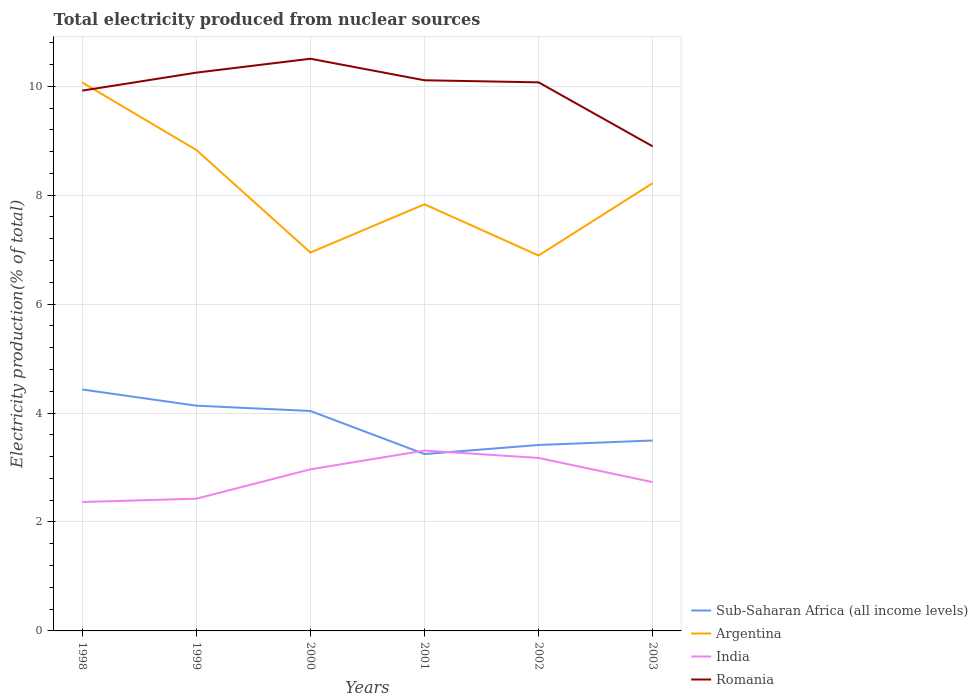Is the number of lines equal to the number of legend labels?
Provide a succinct answer. Yes. Across all years, what is the maximum total electricity produced in Sub-Saharan Africa (all income levels)?
Your answer should be very brief. 3.25. In which year was the total electricity produced in Argentina maximum?
Ensure brevity in your answer.  2002. What is the total total electricity produced in Sub-Saharan Africa (all income levels) in the graph?
Offer a terse response. 0.94. What is the difference between the highest and the second highest total electricity produced in Sub-Saharan Africa (all income levels)?
Ensure brevity in your answer.  1.19. How many lines are there?
Give a very brief answer. 4. Are the values on the major ticks of Y-axis written in scientific E-notation?
Your answer should be very brief. No. Where does the legend appear in the graph?
Offer a very short reply. Bottom right. How many legend labels are there?
Offer a terse response. 4. What is the title of the graph?
Your answer should be very brief. Total electricity produced from nuclear sources. Does "Malaysia" appear as one of the legend labels in the graph?
Make the answer very short. No. What is the label or title of the Y-axis?
Ensure brevity in your answer.  Electricity production(% of total). What is the Electricity production(% of total) of Sub-Saharan Africa (all income levels) in 1998?
Provide a succinct answer. 4.43. What is the Electricity production(% of total) in Argentina in 1998?
Your answer should be compact. 10.07. What is the Electricity production(% of total) in India in 1998?
Keep it short and to the point. 2.37. What is the Electricity production(% of total) of Romania in 1998?
Offer a terse response. 9.92. What is the Electricity production(% of total) of Sub-Saharan Africa (all income levels) in 1999?
Provide a succinct answer. 4.14. What is the Electricity production(% of total) of Argentina in 1999?
Your response must be concise. 8.83. What is the Electricity production(% of total) in India in 1999?
Your response must be concise. 2.43. What is the Electricity production(% of total) of Romania in 1999?
Provide a short and direct response. 10.25. What is the Electricity production(% of total) in Sub-Saharan Africa (all income levels) in 2000?
Your answer should be very brief. 4.04. What is the Electricity production(% of total) in Argentina in 2000?
Ensure brevity in your answer.  6.95. What is the Electricity production(% of total) in India in 2000?
Keep it short and to the point. 2.97. What is the Electricity production(% of total) of Romania in 2000?
Your response must be concise. 10.51. What is the Electricity production(% of total) in Sub-Saharan Africa (all income levels) in 2001?
Make the answer very short. 3.25. What is the Electricity production(% of total) of Argentina in 2001?
Provide a succinct answer. 7.83. What is the Electricity production(% of total) in India in 2001?
Your response must be concise. 3.31. What is the Electricity production(% of total) in Romania in 2001?
Your answer should be compact. 10.11. What is the Electricity production(% of total) of Sub-Saharan Africa (all income levels) in 2002?
Give a very brief answer. 3.41. What is the Electricity production(% of total) in Argentina in 2002?
Your response must be concise. 6.89. What is the Electricity production(% of total) of India in 2002?
Provide a short and direct response. 3.18. What is the Electricity production(% of total) of Romania in 2002?
Provide a short and direct response. 10.07. What is the Electricity production(% of total) of Sub-Saharan Africa (all income levels) in 2003?
Keep it short and to the point. 3.5. What is the Electricity production(% of total) in Argentina in 2003?
Provide a short and direct response. 8.22. What is the Electricity production(% of total) in India in 2003?
Provide a short and direct response. 2.73. What is the Electricity production(% of total) in Romania in 2003?
Keep it short and to the point. 8.9. Across all years, what is the maximum Electricity production(% of total) in Sub-Saharan Africa (all income levels)?
Provide a succinct answer. 4.43. Across all years, what is the maximum Electricity production(% of total) of Argentina?
Keep it short and to the point. 10.07. Across all years, what is the maximum Electricity production(% of total) in India?
Provide a succinct answer. 3.31. Across all years, what is the maximum Electricity production(% of total) of Romania?
Your answer should be very brief. 10.51. Across all years, what is the minimum Electricity production(% of total) of Sub-Saharan Africa (all income levels)?
Provide a succinct answer. 3.25. Across all years, what is the minimum Electricity production(% of total) of Argentina?
Provide a succinct answer. 6.89. Across all years, what is the minimum Electricity production(% of total) in India?
Provide a short and direct response. 2.37. Across all years, what is the minimum Electricity production(% of total) of Romania?
Provide a succinct answer. 8.9. What is the total Electricity production(% of total) in Sub-Saharan Africa (all income levels) in the graph?
Provide a succinct answer. 22.77. What is the total Electricity production(% of total) in Argentina in the graph?
Your response must be concise. 48.8. What is the total Electricity production(% of total) in India in the graph?
Offer a terse response. 16.98. What is the total Electricity production(% of total) in Romania in the graph?
Your answer should be very brief. 59.76. What is the difference between the Electricity production(% of total) in Sub-Saharan Africa (all income levels) in 1998 and that in 1999?
Your answer should be compact. 0.3. What is the difference between the Electricity production(% of total) in Argentina in 1998 and that in 1999?
Your answer should be compact. 1.24. What is the difference between the Electricity production(% of total) in India in 1998 and that in 1999?
Keep it short and to the point. -0.06. What is the difference between the Electricity production(% of total) of Romania in 1998 and that in 1999?
Provide a succinct answer. -0.33. What is the difference between the Electricity production(% of total) of Sub-Saharan Africa (all income levels) in 1998 and that in 2000?
Give a very brief answer. 0.39. What is the difference between the Electricity production(% of total) in Argentina in 1998 and that in 2000?
Keep it short and to the point. 3.12. What is the difference between the Electricity production(% of total) of India in 1998 and that in 2000?
Make the answer very short. -0.6. What is the difference between the Electricity production(% of total) in Romania in 1998 and that in 2000?
Provide a short and direct response. -0.59. What is the difference between the Electricity production(% of total) of Sub-Saharan Africa (all income levels) in 1998 and that in 2001?
Your answer should be compact. 1.19. What is the difference between the Electricity production(% of total) in Argentina in 1998 and that in 2001?
Offer a very short reply. 2.24. What is the difference between the Electricity production(% of total) in India in 1998 and that in 2001?
Offer a terse response. -0.94. What is the difference between the Electricity production(% of total) of Romania in 1998 and that in 2001?
Ensure brevity in your answer.  -0.19. What is the difference between the Electricity production(% of total) of Sub-Saharan Africa (all income levels) in 1998 and that in 2002?
Make the answer very short. 1.02. What is the difference between the Electricity production(% of total) of Argentina in 1998 and that in 2002?
Offer a very short reply. 3.18. What is the difference between the Electricity production(% of total) in India in 1998 and that in 2002?
Provide a succinct answer. -0.81. What is the difference between the Electricity production(% of total) in Romania in 1998 and that in 2002?
Ensure brevity in your answer.  -0.15. What is the difference between the Electricity production(% of total) of Sub-Saharan Africa (all income levels) in 1998 and that in 2003?
Make the answer very short. 0.94. What is the difference between the Electricity production(% of total) of Argentina in 1998 and that in 2003?
Give a very brief answer. 1.85. What is the difference between the Electricity production(% of total) of India in 1998 and that in 2003?
Provide a succinct answer. -0.37. What is the difference between the Electricity production(% of total) of Romania in 1998 and that in 2003?
Your response must be concise. 1.02. What is the difference between the Electricity production(% of total) in Sub-Saharan Africa (all income levels) in 1999 and that in 2000?
Your answer should be compact. 0.1. What is the difference between the Electricity production(% of total) of Argentina in 1999 and that in 2000?
Your answer should be compact. 1.88. What is the difference between the Electricity production(% of total) in India in 1999 and that in 2000?
Ensure brevity in your answer.  -0.54. What is the difference between the Electricity production(% of total) of Romania in 1999 and that in 2000?
Provide a succinct answer. -0.26. What is the difference between the Electricity production(% of total) of Sub-Saharan Africa (all income levels) in 1999 and that in 2001?
Provide a succinct answer. 0.89. What is the difference between the Electricity production(% of total) of Argentina in 1999 and that in 2001?
Ensure brevity in your answer.  1. What is the difference between the Electricity production(% of total) in India in 1999 and that in 2001?
Your answer should be compact. -0.88. What is the difference between the Electricity production(% of total) in Romania in 1999 and that in 2001?
Keep it short and to the point. 0.14. What is the difference between the Electricity production(% of total) of Sub-Saharan Africa (all income levels) in 1999 and that in 2002?
Your response must be concise. 0.72. What is the difference between the Electricity production(% of total) in Argentina in 1999 and that in 2002?
Keep it short and to the point. 1.94. What is the difference between the Electricity production(% of total) of India in 1999 and that in 2002?
Provide a short and direct response. -0.75. What is the difference between the Electricity production(% of total) of Romania in 1999 and that in 2002?
Your answer should be compact. 0.18. What is the difference between the Electricity production(% of total) in Sub-Saharan Africa (all income levels) in 1999 and that in 2003?
Make the answer very short. 0.64. What is the difference between the Electricity production(% of total) in Argentina in 1999 and that in 2003?
Keep it short and to the point. 0.61. What is the difference between the Electricity production(% of total) in India in 1999 and that in 2003?
Offer a terse response. -0.3. What is the difference between the Electricity production(% of total) of Romania in 1999 and that in 2003?
Ensure brevity in your answer.  1.35. What is the difference between the Electricity production(% of total) of Sub-Saharan Africa (all income levels) in 2000 and that in 2001?
Ensure brevity in your answer.  0.79. What is the difference between the Electricity production(% of total) of Argentina in 2000 and that in 2001?
Provide a succinct answer. -0.89. What is the difference between the Electricity production(% of total) of India in 2000 and that in 2001?
Your response must be concise. -0.34. What is the difference between the Electricity production(% of total) of Romania in 2000 and that in 2001?
Offer a very short reply. 0.4. What is the difference between the Electricity production(% of total) of Sub-Saharan Africa (all income levels) in 2000 and that in 2002?
Keep it short and to the point. 0.62. What is the difference between the Electricity production(% of total) in Argentina in 2000 and that in 2002?
Offer a terse response. 0.05. What is the difference between the Electricity production(% of total) of India in 2000 and that in 2002?
Provide a short and direct response. -0.21. What is the difference between the Electricity production(% of total) in Romania in 2000 and that in 2002?
Make the answer very short. 0.43. What is the difference between the Electricity production(% of total) of Sub-Saharan Africa (all income levels) in 2000 and that in 2003?
Provide a short and direct response. 0.54. What is the difference between the Electricity production(% of total) in Argentina in 2000 and that in 2003?
Give a very brief answer. -1.27. What is the difference between the Electricity production(% of total) in India in 2000 and that in 2003?
Make the answer very short. 0.23. What is the difference between the Electricity production(% of total) of Romania in 2000 and that in 2003?
Your answer should be compact. 1.61. What is the difference between the Electricity production(% of total) of Sub-Saharan Africa (all income levels) in 2001 and that in 2002?
Provide a short and direct response. -0.17. What is the difference between the Electricity production(% of total) in Argentina in 2001 and that in 2002?
Offer a terse response. 0.94. What is the difference between the Electricity production(% of total) in India in 2001 and that in 2002?
Keep it short and to the point. 0.14. What is the difference between the Electricity production(% of total) in Romania in 2001 and that in 2002?
Make the answer very short. 0.04. What is the difference between the Electricity production(% of total) in Sub-Saharan Africa (all income levels) in 2001 and that in 2003?
Make the answer very short. -0.25. What is the difference between the Electricity production(% of total) of Argentina in 2001 and that in 2003?
Make the answer very short. -0.39. What is the difference between the Electricity production(% of total) in India in 2001 and that in 2003?
Provide a short and direct response. 0.58. What is the difference between the Electricity production(% of total) in Romania in 2001 and that in 2003?
Keep it short and to the point. 1.21. What is the difference between the Electricity production(% of total) of Sub-Saharan Africa (all income levels) in 2002 and that in 2003?
Your answer should be compact. -0.08. What is the difference between the Electricity production(% of total) of Argentina in 2002 and that in 2003?
Ensure brevity in your answer.  -1.33. What is the difference between the Electricity production(% of total) in India in 2002 and that in 2003?
Make the answer very short. 0.44. What is the difference between the Electricity production(% of total) of Romania in 2002 and that in 2003?
Your answer should be compact. 1.17. What is the difference between the Electricity production(% of total) in Sub-Saharan Africa (all income levels) in 1998 and the Electricity production(% of total) in Argentina in 1999?
Offer a terse response. -4.4. What is the difference between the Electricity production(% of total) in Sub-Saharan Africa (all income levels) in 1998 and the Electricity production(% of total) in India in 1999?
Your answer should be very brief. 2.01. What is the difference between the Electricity production(% of total) in Sub-Saharan Africa (all income levels) in 1998 and the Electricity production(% of total) in Romania in 1999?
Give a very brief answer. -5.82. What is the difference between the Electricity production(% of total) of Argentina in 1998 and the Electricity production(% of total) of India in 1999?
Offer a terse response. 7.64. What is the difference between the Electricity production(% of total) of Argentina in 1998 and the Electricity production(% of total) of Romania in 1999?
Offer a very short reply. -0.18. What is the difference between the Electricity production(% of total) in India in 1998 and the Electricity production(% of total) in Romania in 1999?
Make the answer very short. -7.88. What is the difference between the Electricity production(% of total) in Sub-Saharan Africa (all income levels) in 1998 and the Electricity production(% of total) in Argentina in 2000?
Provide a short and direct response. -2.51. What is the difference between the Electricity production(% of total) in Sub-Saharan Africa (all income levels) in 1998 and the Electricity production(% of total) in India in 2000?
Make the answer very short. 1.47. What is the difference between the Electricity production(% of total) in Sub-Saharan Africa (all income levels) in 1998 and the Electricity production(% of total) in Romania in 2000?
Ensure brevity in your answer.  -6.07. What is the difference between the Electricity production(% of total) in Argentina in 1998 and the Electricity production(% of total) in India in 2000?
Keep it short and to the point. 7.1. What is the difference between the Electricity production(% of total) in Argentina in 1998 and the Electricity production(% of total) in Romania in 2000?
Your answer should be very brief. -0.44. What is the difference between the Electricity production(% of total) in India in 1998 and the Electricity production(% of total) in Romania in 2000?
Your answer should be compact. -8.14. What is the difference between the Electricity production(% of total) in Sub-Saharan Africa (all income levels) in 1998 and the Electricity production(% of total) in Argentina in 2001?
Ensure brevity in your answer.  -3.4. What is the difference between the Electricity production(% of total) in Sub-Saharan Africa (all income levels) in 1998 and the Electricity production(% of total) in India in 2001?
Provide a short and direct response. 1.12. What is the difference between the Electricity production(% of total) of Sub-Saharan Africa (all income levels) in 1998 and the Electricity production(% of total) of Romania in 2001?
Provide a short and direct response. -5.68. What is the difference between the Electricity production(% of total) in Argentina in 1998 and the Electricity production(% of total) in India in 2001?
Keep it short and to the point. 6.76. What is the difference between the Electricity production(% of total) of Argentina in 1998 and the Electricity production(% of total) of Romania in 2001?
Give a very brief answer. -0.04. What is the difference between the Electricity production(% of total) in India in 1998 and the Electricity production(% of total) in Romania in 2001?
Give a very brief answer. -7.74. What is the difference between the Electricity production(% of total) of Sub-Saharan Africa (all income levels) in 1998 and the Electricity production(% of total) of Argentina in 2002?
Give a very brief answer. -2.46. What is the difference between the Electricity production(% of total) of Sub-Saharan Africa (all income levels) in 1998 and the Electricity production(% of total) of India in 2002?
Your answer should be compact. 1.26. What is the difference between the Electricity production(% of total) of Sub-Saharan Africa (all income levels) in 1998 and the Electricity production(% of total) of Romania in 2002?
Give a very brief answer. -5.64. What is the difference between the Electricity production(% of total) of Argentina in 1998 and the Electricity production(% of total) of India in 2002?
Ensure brevity in your answer.  6.89. What is the difference between the Electricity production(% of total) in Argentina in 1998 and the Electricity production(% of total) in Romania in 2002?
Keep it short and to the point. -0. What is the difference between the Electricity production(% of total) in India in 1998 and the Electricity production(% of total) in Romania in 2002?
Ensure brevity in your answer.  -7.71. What is the difference between the Electricity production(% of total) in Sub-Saharan Africa (all income levels) in 1998 and the Electricity production(% of total) in Argentina in 2003?
Keep it short and to the point. -3.79. What is the difference between the Electricity production(% of total) of Sub-Saharan Africa (all income levels) in 1998 and the Electricity production(% of total) of India in 2003?
Make the answer very short. 1.7. What is the difference between the Electricity production(% of total) in Sub-Saharan Africa (all income levels) in 1998 and the Electricity production(% of total) in Romania in 2003?
Ensure brevity in your answer.  -4.46. What is the difference between the Electricity production(% of total) in Argentina in 1998 and the Electricity production(% of total) in India in 2003?
Offer a terse response. 7.34. What is the difference between the Electricity production(% of total) of Argentina in 1998 and the Electricity production(% of total) of Romania in 2003?
Provide a succinct answer. 1.17. What is the difference between the Electricity production(% of total) in India in 1998 and the Electricity production(% of total) in Romania in 2003?
Your answer should be compact. -6.53. What is the difference between the Electricity production(% of total) in Sub-Saharan Africa (all income levels) in 1999 and the Electricity production(% of total) in Argentina in 2000?
Keep it short and to the point. -2.81. What is the difference between the Electricity production(% of total) in Sub-Saharan Africa (all income levels) in 1999 and the Electricity production(% of total) in India in 2000?
Give a very brief answer. 1.17. What is the difference between the Electricity production(% of total) of Sub-Saharan Africa (all income levels) in 1999 and the Electricity production(% of total) of Romania in 2000?
Your response must be concise. -6.37. What is the difference between the Electricity production(% of total) in Argentina in 1999 and the Electricity production(% of total) in India in 2000?
Your answer should be compact. 5.86. What is the difference between the Electricity production(% of total) in Argentina in 1999 and the Electricity production(% of total) in Romania in 2000?
Keep it short and to the point. -1.67. What is the difference between the Electricity production(% of total) in India in 1999 and the Electricity production(% of total) in Romania in 2000?
Provide a succinct answer. -8.08. What is the difference between the Electricity production(% of total) in Sub-Saharan Africa (all income levels) in 1999 and the Electricity production(% of total) in Argentina in 2001?
Ensure brevity in your answer.  -3.7. What is the difference between the Electricity production(% of total) in Sub-Saharan Africa (all income levels) in 1999 and the Electricity production(% of total) in India in 2001?
Make the answer very short. 0.82. What is the difference between the Electricity production(% of total) in Sub-Saharan Africa (all income levels) in 1999 and the Electricity production(% of total) in Romania in 2001?
Provide a short and direct response. -5.97. What is the difference between the Electricity production(% of total) in Argentina in 1999 and the Electricity production(% of total) in India in 2001?
Provide a succinct answer. 5.52. What is the difference between the Electricity production(% of total) of Argentina in 1999 and the Electricity production(% of total) of Romania in 2001?
Offer a very short reply. -1.28. What is the difference between the Electricity production(% of total) of India in 1999 and the Electricity production(% of total) of Romania in 2001?
Offer a very short reply. -7.68. What is the difference between the Electricity production(% of total) in Sub-Saharan Africa (all income levels) in 1999 and the Electricity production(% of total) in Argentina in 2002?
Your answer should be compact. -2.76. What is the difference between the Electricity production(% of total) in Sub-Saharan Africa (all income levels) in 1999 and the Electricity production(% of total) in India in 2002?
Give a very brief answer. 0.96. What is the difference between the Electricity production(% of total) in Sub-Saharan Africa (all income levels) in 1999 and the Electricity production(% of total) in Romania in 2002?
Your answer should be very brief. -5.94. What is the difference between the Electricity production(% of total) of Argentina in 1999 and the Electricity production(% of total) of India in 2002?
Your answer should be compact. 5.65. What is the difference between the Electricity production(% of total) of Argentina in 1999 and the Electricity production(% of total) of Romania in 2002?
Offer a terse response. -1.24. What is the difference between the Electricity production(% of total) of India in 1999 and the Electricity production(% of total) of Romania in 2002?
Make the answer very short. -7.64. What is the difference between the Electricity production(% of total) of Sub-Saharan Africa (all income levels) in 1999 and the Electricity production(% of total) of Argentina in 2003?
Provide a succinct answer. -4.09. What is the difference between the Electricity production(% of total) in Sub-Saharan Africa (all income levels) in 1999 and the Electricity production(% of total) in India in 2003?
Your response must be concise. 1.4. What is the difference between the Electricity production(% of total) of Sub-Saharan Africa (all income levels) in 1999 and the Electricity production(% of total) of Romania in 2003?
Keep it short and to the point. -4.76. What is the difference between the Electricity production(% of total) of Argentina in 1999 and the Electricity production(% of total) of India in 2003?
Offer a very short reply. 6.1. What is the difference between the Electricity production(% of total) in Argentina in 1999 and the Electricity production(% of total) in Romania in 2003?
Make the answer very short. -0.07. What is the difference between the Electricity production(% of total) in India in 1999 and the Electricity production(% of total) in Romania in 2003?
Offer a terse response. -6.47. What is the difference between the Electricity production(% of total) of Sub-Saharan Africa (all income levels) in 2000 and the Electricity production(% of total) of Argentina in 2001?
Your answer should be compact. -3.79. What is the difference between the Electricity production(% of total) in Sub-Saharan Africa (all income levels) in 2000 and the Electricity production(% of total) in India in 2001?
Offer a very short reply. 0.73. What is the difference between the Electricity production(% of total) in Sub-Saharan Africa (all income levels) in 2000 and the Electricity production(% of total) in Romania in 2001?
Provide a short and direct response. -6.07. What is the difference between the Electricity production(% of total) in Argentina in 2000 and the Electricity production(% of total) in India in 2001?
Offer a terse response. 3.64. What is the difference between the Electricity production(% of total) of Argentina in 2000 and the Electricity production(% of total) of Romania in 2001?
Your response must be concise. -3.16. What is the difference between the Electricity production(% of total) in India in 2000 and the Electricity production(% of total) in Romania in 2001?
Provide a short and direct response. -7.14. What is the difference between the Electricity production(% of total) of Sub-Saharan Africa (all income levels) in 2000 and the Electricity production(% of total) of Argentina in 2002?
Your response must be concise. -2.85. What is the difference between the Electricity production(% of total) of Sub-Saharan Africa (all income levels) in 2000 and the Electricity production(% of total) of India in 2002?
Your response must be concise. 0.86. What is the difference between the Electricity production(% of total) in Sub-Saharan Africa (all income levels) in 2000 and the Electricity production(% of total) in Romania in 2002?
Make the answer very short. -6.03. What is the difference between the Electricity production(% of total) in Argentina in 2000 and the Electricity production(% of total) in India in 2002?
Your answer should be compact. 3.77. What is the difference between the Electricity production(% of total) in Argentina in 2000 and the Electricity production(% of total) in Romania in 2002?
Your answer should be very brief. -3.12. What is the difference between the Electricity production(% of total) of India in 2000 and the Electricity production(% of total) of Romania in 2002?
Give a very brief answer. -7.11. What is the difference between the Electricity production(% of total) in Sub-Saharan Africa (all income levels) in 2000 and the Electricity production(% of total) in Argentina in 2003?
Keep it short and to the point. -4.18. What is the difference between the Electricity production(% of total) in Sub-Saharan Africa (all income levels) in 2000 and the Electricity production(% of total) in India in 2003?
Offer a very short reply. 1.31. What is the difference between the Electricity production(% of total) of Sub-Saharan Africa (all income levels) in 2000 and the Electricity production(% of total) of Romania in 2003?
Your answer should be compact. -4.86. What is the difference between the Electricity production(% of total) in Argentina in 2000 and the Electricity production(% of total) in India in 2003?
Ensure brevity in your answer.  4.22. What is the difference between the Electricity production(% of total) of Argentina in 2000 and the Electricity production(% of total) of Romania in 2003?
Your response must be concise. -1.95. What is the difference between the Electricity production(% of total) in India in 2000 and the Electricity production(% of total) in Romania in 2003?
Your answer should be compact. -5.93. What is the difference between the Electricity production(% of total) of Sub-Saharan Africa (all income levels) in 2001 and the Electricity production(% of total) of Argentina in 2002?
Your response must be concise. -3.64. What is the difference between the Electricity production(% of total) in Sub-Saharan Africa (all income levels) in 2001 and the Electricity production(% of total) in India in 2002?
Keep it short and to the point. 0.07. What is the difference between the Electricity production(% of total) of Sub-Saharan Africa (all income levels) in 2001 and the Electricity production(% of total) of Romania in 2002?
Ensure brevity in your answer.  -6.82. What is the difference between the Electricity production(% of total) of Argentina in 2001 and the Electricity production(% of total) of India in 2002?
Ensure brevity in your answer.  4.66. What is the difference between the Electricity production(% of total) in Argentina in 2001 and the Electricity production(% of total) in Romania in 2002?
Offer a terse response. -2.24. What is the difference between the Electricity production(% of total) of India in 2001 and the Electricity production(% of total) of Romania in 2002?
Your answer should be very brief. -6.76. What is the difference between the Electricity production(% of total) in Sub-Saharan Africa (all income levels) in 2001 and the Electricity production(% of total) in Argentina in 2003?
Your response must be concise. -4.97. What is the difference between the Electricity production(% of total) in Sub-Saharan Africa (all income levels) in 2001 and the Electricity production(% of total) in India in 2003?
Your answer should be compact. 0.52. What is the difference between the Electricity production(% of total) in Sub-Saharan Africa (all income levels) in 2001 and the Electricity production(% of total) in Romania in 2003?
Your answer should be compact. -5.65. What is the difference between the Electricity production(% of total) of Argentina in 2001 and the Electricity production(% of total) of India in 2003?
Provide a short and direct response. 5.1. What is the difference between the Electricity production(% of total) in Argentina in 2001 and the Electricity production(% of total) in Romania in 2003?
Your answer should be very brief. -1.06. What is the difference between the Electricity production(% of total) in India in 2001 and the Electricity production(% of total) in Romania in 2003?
Provide a short and direct response. -5.59. What is the difference between the Electricity production(% of total) of Sub-Saharan Africa (all income levels) in 2002 and the Electricity production(% of total) of Argentina in 2003?
Keep it short and to the point. -4.81. What is the difference between the Electricity production(% of total) in Sub-Saharan Africa (all income levels) in 2002 and the Electricity production(% of total) in India in 2003?
Your answer should be very brief. 0.68. What is the difference between the Electricity production(% of total) in Sub-Saharan Africa (all income levels) in 2002 and the Electricity production(% of total) in Romania in 2003?
Keep it short and to the point. -5.48. What is the difference between the Electricity production(% of total) in Argentina in 2002 and the Electricity production(% of total) in India in 2003?
Make the answer very short. 4.16. What is the difference between the Electricity production(% of total) of Argentina in 2002 and the Electricity production(% of total) of Romania in 2003?
Provide a succinct answer. -2. What is the difference between the Electricity production(% of total) of India in 2002 and the Electricity production(% of total) of Romania in 2003?
Offer a very short reply. -5.72. What is the average Electricity production(% of total) in Sub-Saharan Africa (all income levels) per year?
Your response must be concise. 3.79. What is the average Electricity production(% of total) of Argentina per year?
Offer a very short reply. 8.13. What is the average Electricity production(% of total) in India per year?
Ensure brevity in your answer.  2.83. What is the average Electricity production(% of total) of Romania per year?
Your answer should be compact. 9.96. In the year 1998, what is the difference between the Electricity production(% of total) in Sub-Saharan Africa (all income levels) and Electricity production(% of total) in Argentina?
Your response must be concise. -5.64. In the year 1998, what is the difference between the Electricity production(% of total) in Sub-Saharan Africa (all income levels) and Electricity production(% of total) in India?
Offer a very short reply. 2.07. In the year 1998, what is the difference between the Electricity production(% of total) of Sub-Saharan Africa (all income levels) and Electricity production(% of total) of Romania?
Provide a succinct answer. -5.49. In the year 1998, what is the difference between the Electricity production(% of total) of Argentina and Electricity production(% of total) of India?
Offer a very short reply. 7.7. In the year 1998, what is the difference between the Electricity production(% of total) in Argentina and Electricity production(% of total) in Romania?
Provide a succinct answer. 0.15. In the year 1998, what is the difference between the Electricity production(% of total) of India and Electricity production(% of total) of Romania?
Your response must be concise. -7.55. In the year 1999, what is the difference between the Electricity production(% of total) in Sub-Saharan Africa (all income levels) and Electricity production(% of total) in Argentina?
Ensure brevity in your answer.  -4.7. In the year 1999, what is the difference between the Electricity production(% of total) in Sub-Saharan Africa (all income levels) and Electricity production(% of total) in India?
Offer a terse response. 1.71. In the year 1999, what is the difference between the Electricity production(% of total) of Sub-Saharan Africa (all income levels) and Electricity production(% of total) of Romania?
Provide a succinct answer. -6.11. In the year 1999, what is the difference between the Electricity production(% of total) in Argentina and Electricity production(% of total) in India?
Offer a very short reply. 6.4. In the year 1999, what is the difference between the Electricity production(% of total) in Argentina and Electricity production(% of total) in Romania?
Your answer should be very brief. -1.42. In the year 1999, what is the difference between the Electricity production(% of total) in India and Electricity production(% of total) in Romania?
Make the answer very short. -7.82. In the year 2000, what is the difference between the Electricity production(% of total) in Sub-Saharan Africa (all income levels) and Electricity production(% of total) in Argentina?
Offer a terse response. -2.91. In the year 2000, what is the difference between the Electricity production(% of total) of Sub-Saharan Africa (all income levels) and Electricity production(% of total) of India?
Provide a short and direct response. 1.07. In the year 2000, what is the difference between the Electricity production(% of total) of Sub-Saharan Africa (all income levels) and Electricity production(% of total) of Romania?
Offer a terse response. -6.47. In the year 2000, what is the difference between the Electricity production(% of total) in Argentina and Electricity production(% of total) in India?
Offer a terse response. 3.98. In the year 2000, what is the difference between the Electricity production(% of total) in Argentina and Electricity production(% of total) in Romania?
Provide a short and direct response. -3.56. In the year 2000, what is the difference between the Electricity production(% of total) of India and Electricity production(% of total) of Romania?
Ensure brevity in your answer.  -7.54. In the year 2001, what is the difference between the Electricity production(% of total) of Sub-Saharan Africa (all income levels) and Electricity production(% of total) of Argentina?
Your answer should be compact. -4.59. In the year 2001, what is the difference between the Electricity production(% of total) of Sub-Saharan Africa (all income levels) and Electricity production(% of total) of India?
Make the answer very short. -0.06. In the year 2001, what is the difference between the Electricity production(% of total) in Sub-Saharan Africa (all income levels) and Electricity production(% of total) in Romania?
Make the answer very short. -6.86. In the year 2001, what is the difference between the Electricity production(% of total) of Argentina and Electricity production(% of total) of India?
Give a very brief answer. 4.52. In the year 2001, what is the difference between the Electricity production(% of total) of Argentina and Electricity production(% of total) of Romania?
Offer a terse response. -2.28. In the year 2001, what is the difference between the Electricity production(% of total) of India and Electricity production(% of total) of Romania?
Your response must be concise. -6.8. In the year 2002, what is the difference between the Electricity production(% of total) of Sub-Saharan Africa (all income levels) and Electricity production(% of total) of Argentina?
Your response must be concise. -3.48. In the year 2002, what is the difference between the Electricity production(% of total) in Sub-Saharan Africa (all income levels) and Electricity production(% of total) in India?
Make the answer very short. 0.24. In the year 2002, what is the difference between the Electricity production(% of total) in Sub-Saharan Africa (all income levels) and Electricity production(% of total) in Romania?
Make the answer very short. -6.66. In the year 2002, what is the difference between the Electricity production(% of total) in Argentina and Electricity production(% of total) in India?
Provide a succinct answer. 3.72. In the year 2002, what is the difference between the Electricity production(% of total) of Argentina and Electricity production(% of total) of Romania?
Offer a terse response. -3.18. In the year 2002, what is the difference between the Electricity production(% of total) in India and Electricity production(% of total) in Romania?
Make the answer very short. -6.9. In the year 2003, what is the difference between the Electricity production(% of total) of Sub-Saharan Africa (all income levels) and Electricity production(% of total) of Argentina?
Offer a very short reply. -4.72. In the year 2003, what is the difference between the Electricity production(% of total) in Sub-Saharan Africa (all income levels) and Electricity production(% of total) in India?
Your response must be concise. 0.76. In the year 2003, what is the difference between the Electricity production(% of total) of Sub-Saharan Africa (all income levels) and Electricity production(% of total) of Romania?
Provide a short and direct response. -5.4. In the year 2003, what is the difference between the Electricity production(% of total) in Argentina and Electricity production(% of total) in India?
Your answer should be very brief. 5.49. In the year 2003, what is the difference between the Electricity production(% of total) of Argentina and Electricity production(% of total) of Romania?
Your answer should be very brief. -0.68. In the year 2003, what is the difference between the Electricity production(% of total) in India and Electricity production(% of total) in Romania?
Provide a succinct answer. -6.17. What is the ratio of the Electricity production(% of total) in Sub-Saharan Africa (all income levels) in 1998 to that in 1999?
Keep it short and to the point. 1.07. What is the ratio of the Electricity production(% of total) of Argentina in 1998 to that in 1999?
Offer a very short reply. 1.14. What is the ratio of the Electricity production(% of total) of India in 1998 to that in 1999?
Give a very brief answer. 0.97. What is the ratio of the Electricity production(% of total) of Romania in 1998 to that in 1999?
Keep it short and to the point. 0.97. What is the ratio of the Electricity production(% of total) of Sub-Saharan Africa (all income levels) in 1998 to that in 2000?
Offer a terse response. 1.1. What is the ratio of the Electricity production(% of total) in Argentina in 1998 to that in 2000?
Ensure brevity in your answer.  1.45. What is the ratio of the Electricity production(% of total) in India in 1998 to that in 2000?
Provide a succinct answer. 0.8. What is the ratio of the Electricity production(% of total) of Romania in 1998 to that in 2000?
Offer a terse response. 0.94. What is the ratio of the Electricity production(% of total) in Sub-Saharan Africa (all income levels) in 1998 to that in 2001?
Offer a very short reply. 1.36. What is the ratio of the Electricity production(% of total) in Argentina in 1998 to that in 2001?
Offer a very short reply. 1.29. What is the ratio of the Electricity production(% of total) of India in 1998 to that in 2001?
Give a very brief answer. 0.71. What is the ratio of the Electricity production(% of total) in Romania in 1998 to that in 2001?
Give a very brief answer. 0.98. What is the ratio of the Electricity production(% of total) in Sub-Saharan Africa (all income levels) in 1998 to that in 2002?
Give a very brief answer. 1.3. What is the ratio of the Electricity production(% of total) of Argentina in 1998 to that in 2002?
Offer a very short reply. 1.46. What is the ratio of the Electricity production(% of total) in India in 1998 to that in 2002?
Keep it short and to the point. 0.75. What is the ratio of the Electricity production(% of total) in Romania in 1998 to that in 2002?
Offer a very short reply. 0.98. What is the ratio of the Electricity production(% of total) of Sub-Saharan Africa (all income levels) in 1998 to that in 2003?
Offer a terse response. 1.27. What is the ratio of the Electricity production(% of total) in Argentina in 1998 to that in 2003?
Your response must be concise. 1.22. What is the ratio of the Electricity production(% of total) in India in 1998 to that in 2003?
Provide a succinct answer. 0.87. What is the ratio of the Electricity production(% of total) of Romania in 1998 to that in 2003?
Provide a short and direct response. 1.11. What is the ratio of the Electricity production(% of total) of Sub-Saharan Africa (all income levels) in 1999 to that in 2000?
Offer a very short reply. 1.02. What is the ratio of the Electricity production(% of total) of Argentina in 1999 to that in 2000?
Ensure brevity in your answer.  1.27. What is the ratio of the Electricity production(% of total) in India in 1999 to that in 2000?
Your answer should be very brief. 0.82. What is the ratio of the Electricity production(% of total) in Romania in 1999 to that in 2000?
Provide a short and direct response. 0.98. What is the ratio of the Electricity production(% of total) of Sub-Saharan Africa (all income levels) in 1999 to that in 2001?
Offer a very short reply. 1.27. What is the ratio of the Electricity production(% of total) in Argentina in 1999 to that in 2001?
Your answer should be very brief. 1.13. What is the ratio of the Electricity production(% of total) in India in 1999 to that in 2001?
Your answer should be compact. 0.73. What is the ratio of the Electricity production(% of total) of Romania in 1999 to that in 2001?
Provide a succinct answer. 1.01. What is the ratio of the Electricity production(% of total) of Sub-Saharan Africa (all income levels) in 1999 to that in 2002?
Your answer should be very brief. 1.21. What is the ratio of the Electricity production(% of total) of Argentina in 1999 to that in 2002?
Your response must be concise. 1.28. What is the ratio of the Electricity production(% of total) in India in 1999 to that in 2002?
Your answer should be very brief. 0.76. What is the ratio of the Electricity production(% of total) in Romania in 1999 to that in 2002?
Offer a terse response. 1.02. What is the ratio of the Electricity production(% of total) in Sub-Saharan Africa (all income levels) in 1999 to that in 2003?
Keep it short and to the point. 1.18. What is the ratio of the Electricity production(% of total) in Argentina in 1999 to that in 2003?
Provide a short and direct response. 1.07. What is the ratio of the Electricity production(% of total) in India in 1999 to that in 2003?
Make the answer very short. 0.89. What is the ratio of the Electricity production(% of total) in Romania in 1999 to that in 2003?
Provide a succinct answer. 1.15. What is the ratio of the Electricity production(% of total) in Sub-Saharan Africa (all income levels) in 2000 to that in 2001?
Your answer should be very brief. 1.24. What is the ratio of the Electricity production(% of total) of Argentina in 2000 to that in 2001?
Ensure brevity in your answer.  0.89. What is the ratio of the Electricity production(% of total) of India in 2000 to that in 2001?
Offer a terse response. 0.9. What is the ratio of the Electricity production(% of total) in Romania in 2000 to that in 2001?
Provide a succinct answer. 1.04. What is the ratio of the Electricity production(% of total) of Sub-Saharan Africa (all income levels) in 2000 to that in 2002?
Make the answer very short. 1.18. What is the ratio of the Electricity production(% of total) in Argentina in 2000 to that in 2002?
Your response must be concise. 1.01. What is the ratio of the Electricity production(% of total) of India in 2000 to that in 2002?
Make the answer very short. 0.93. What is the ratio of the Electricity production(% of total) of Romania in 2000 to that in 2002?
Offer a terse response. 1.04. What is the ratio of the Electricity production(% of total) of Sub-Saharan Africa (all income levels) in 2000 to that in 2003?
Your answer should be compact. 1.16. What is the ratio of the Electricity production(% of total) of Argentina in 2000 to that in 2003?
Give a very brief answer. 0.85. What is the ratio of the Electricity production(% of total) of India in 2000 to that in 2003?
Keep it short and to the point. 1.09. What is the ratio of the Electricity production(% of total) of Romania in 2000 to that in 2003?
Your answer should be compact. 1.18. What is the ratio of the Electricity production(% of total) of Sub-Saharan Africa (all income levels) in 2001 to that in 2002?
Give a very brief answer. 0.95. What is the ratio of the Electricity production(% of total) in Argentina in 2001 to that in 2002?
Provide a short and direct response. 1.14. What is the ratio of the Electricity production(% of total) of India in 2001 to that in 2002?
Your response must be concise. 1.04. What is the ratio of the Electricity production(% of total) in Romania in 2001 to that in 2002?
Keep it short and to the point. 1. What is the ratio of the Electricity production(% of total) of Sub-Saharan Africa (all income levels) in 2001 to that in 2003?
Offer a very short reply. 0.93. What is the ratio of the Electricity production(% of total) of Argentina in 2001 to that in 2003?
Offer a very short reply. 0.95. What is the ratio of the Electricity production(% of total) in India in 2001 to that in 2003?
Provide a succinct answer. 1.21. What is the ratio of the Electricity production(% of total) of Romania in 2001 to that in 2003?
Provide a short and direct response. 1.14. What is the ratio of the Electricity production(% of total) in Sub-Saharan Africa (all income levels) in 2002 to that in 2003?
Keep it short and to the point. 0.98. What is the ratio of the Electricity production(% of total) in Argentina in 2002 to that in 2003?
Give a very brief answer. 0.84. What is the ratio of the Electricity production(% of total) in India in 2002 to that in 2003?
Keep it short and to the point. 1.16. What is the ratio of the Electricity production(% of total) in Romania in 2002 to that in 2003?
Your answer should be very brief. 1.13. What is the difference between the highest and the second highest Electricity production(% of total) of Sub-Saharan Africa (all income levels)?
Keep it short and to the point. 0.3. What is the difference between the highest and the second highest Electricity production(% of total) of Argentina?
Offer a very short reply. 1.24. What is the difference between the highest and the second highest Electricity production(% of total) of India?
Keep it short and to the point. 0.14. What is the difference between the highest and the second highest Electricity production(% of total) in Romania?
Your answer should be very brief. 0.26. What is the difference between the highest and the lowest Electricity production(% of total) of Sub-Saharan Africa (all income levels)?
Provide a short and direct response. 1.19. What is the difference between the highest and the lowest Electricity production(% of total) in Argentina?
Your response must be concise. 3.18. What is the difference between the highest and the lowest Electricity production(% of total) in India?
Provide a succinct answer. 0.94. What is the difference between the highest and the lowest Electricity production(% of total) in Romania?
Your answer should be very brief. 1.61. 